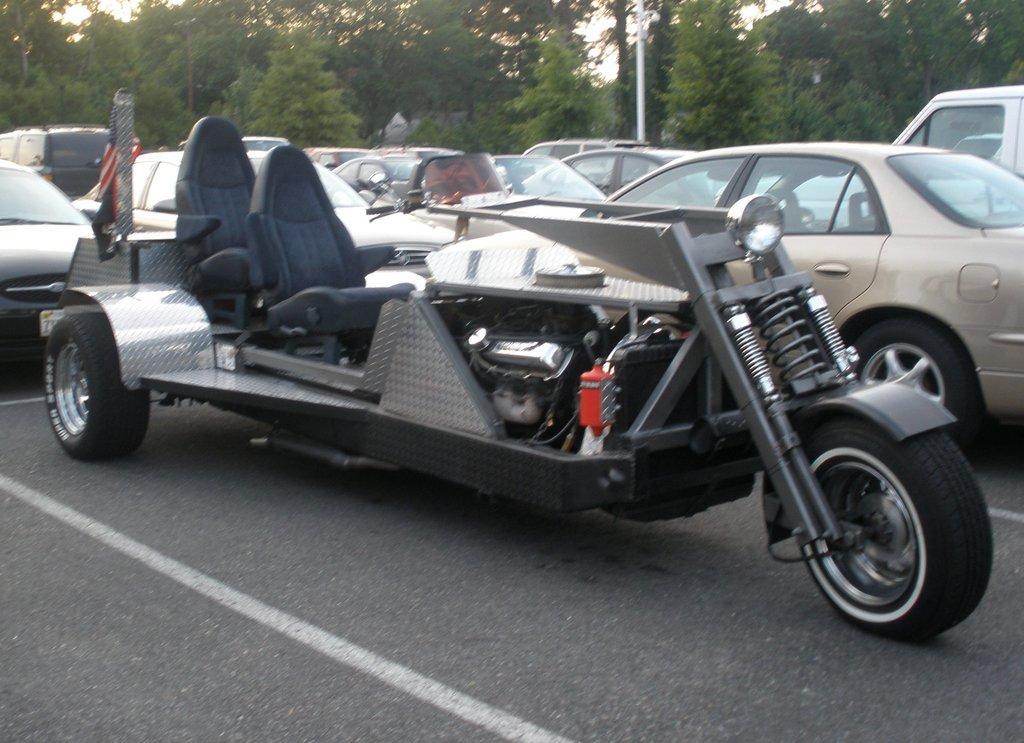Could you give a brief overview of what you see in this image? Here we can see vehicles on the road and there is a flag on this vehicle. In the background there are trees,pole and sky. 